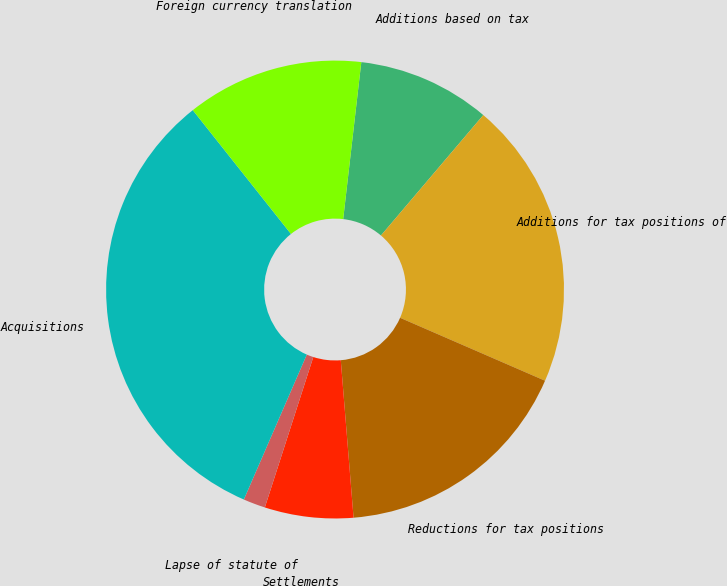Convert chart. <chart><loc_0><loc_0><loc_500><loc_500><pie_chart><fcel>Additions based on tax<fcel>Additions for tax positions of<fcel>Reductions for tax positions<fcel>Settlements<fcel>Lapse of statute of<fcel>Acquisitions<fcel>Foreign currency translation<nl><fcel>9.38%<fcel>20.31%<fcel>17.19%<fcel>6.25%<fcel>1.56%<fcel>32.81%<fcel>12.5%<nl></chart> 